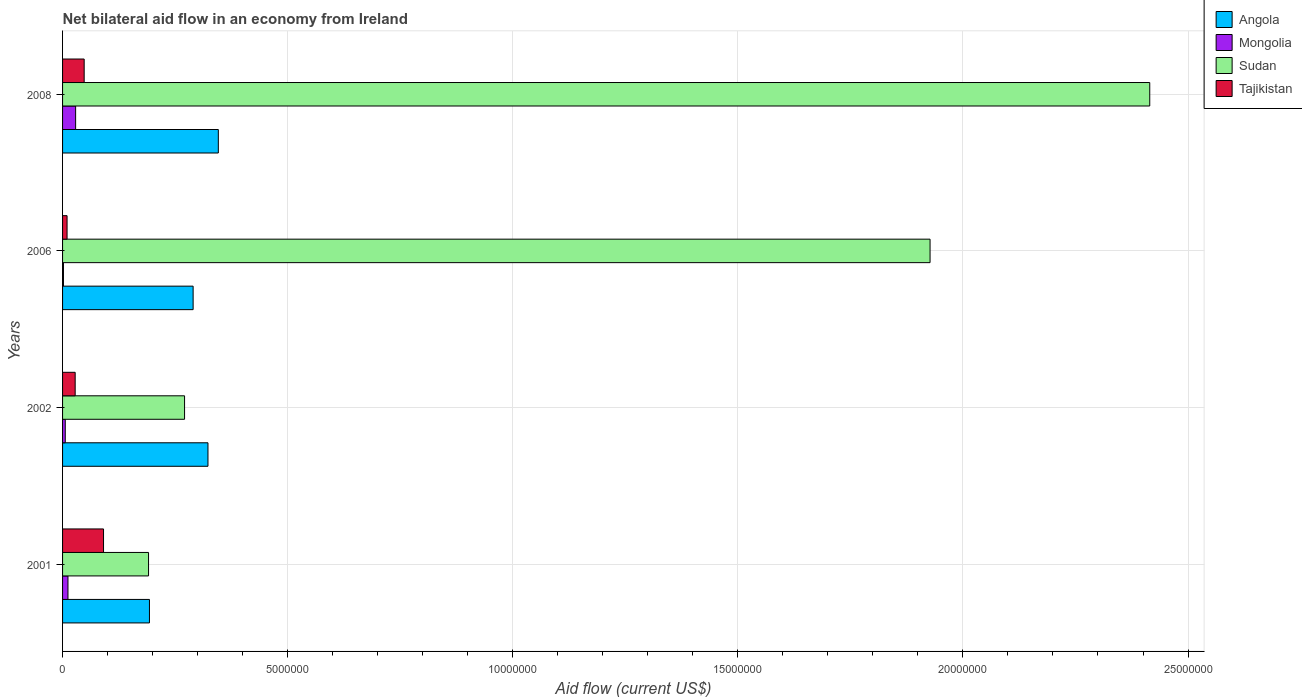How many different coloured bars are there?
Your response must be concise. 4. How many groups of bars are there?
Your response must be concise. 4. Are the number of bars per tick equal to the number of legend labels?
Your answer should be compact. Yes. Are the number of bars on each tick of the Y-axis equal?
Keep it short and to the point. Yes. How many bars are there on the 4th tick from the bottom?
Your response must be concise. 4. What is the net bilateral aid flow in Sudan in 2008?
Your answer should be compact. 2.42e+07. Across all years, what is the maximum net bilateral aid flow in Mongolia?
Your answer should be compact. 2.90e+05. In which year was the net bilateral aid flow in Tajikistan maximum?
Offer a very short reply. 2001. What is the total net bilateral aid flow in Sudan in the graph?
Give a very brief answer. 4.80e+07. What is the difference between the net bilateral aid flow in Angola in 2008 and the net bilateral aid flow in Sudan in 2002?
Provide a short and direct response. 7.50e+05. What is the average net bilateral aid flow in Tajikistan per year?
Make the answer very short. 4.42e+05. In the year 2001, what is the difference between the net bilateral aid flow in Mongolia and net bilateral aid flow in Sudan?
Offer a very short reply. -1.79e+06. In how many years, is the net bilateral aid flow in Mongolia greater than 5000000 US$?
Offer a very short reply. 0. What is the ratio of the net bilateral aid flow in Angola in 2001 to that in 2006?
Your answer should be compact. 0.67. What is the difference between the highest and the lowest net bilateral aid flow in Tajikistan?
Provide a succinct answer. 8.10e+05. In how many years, is the net bilateral aid flow in Mongolia greater than the average net bilateral aid flow in Mongolia taken over all years?
Your answer should be compact. 1. Is the sum of the net bilateral aid flow in Angola in 2002 and 2006 greater than the maximum net bilateral aid flow in Mongolia across all years?
Make the answer very short. Yes. What does the 4th bar from the top in 2008 represents?
Make the answer very short. Angola. What does the 1st bar from the bottom in 2006 represents?
Offer a very short reply. Angola. Is it the case that in every year, the sum of the net bilateral aid flow in Angola and net bilateral aid flow in Sudan is greater than the net bilateral aid flow in Tajikistan?
Provide a succinct answer. Yes. Are all the bars in the graph horizontal?
Keep it short and to the point. Yes. What is the difference between two consecutive major ticks on the X-axis?
Offer a very short reply. 5.00e+06. Does the graph contain grids?
Offer a very short reply. Yes. How many legend labels are there?
Offer a terse response. 4. How are the legend labels stacked?
Your answer should be compact. Vertical. What is the title of the graph?
Give a very brief answer. Net bilateral aid flow in an economy from Ireland. Does "United States" appear as one of the legend labels in the graph?
Provide a short and direct response. No. What is the label or title of the X-axis?
Your response must be concise. Aid flow (current US$). What is the Aid flow (current US$) of Angola in 2001?
Your response must be concise. 1.93e+06. What is the Aid flow (current US$) of Mongolia in 2001?
Offer a very short reply. 1.20e+05. What is the Aid flow (current US$) in Sudan in 2001?
Your answer should be compact. 1.91e+06. What is the Aid flow (current US$) of Tajikistan in 2001?
Keep it short and to the point. 9.10e+05. What is the Aid flow (current US$) in Angola in 2002?
Keep it short and to the point. 3.23e+06. What is the Aid flow (current US$) in Mongolia in 2002?
Provide a succinct answer. 6.00e+04. What is the Aid flow (current US$) of Sudan in 2002?
Ensure brevity in your answer.  2.71e+06. What is the Aid flow (current US$) of Angola in 2006?
Give a very brief answer. 2.90e+06. What is the Aid flow (current US$) in Mongolia in 2006?
Provide a short and direct response. 2.00e+04. What is the Aid flow (current US$) in Sudan in 2006?
Make the answer very short. 1.93e+07. What is the Aid flow (current US$) of Tajikistan in 2006?
Your answer should be compact. 1.00e+05. What is the Aid flow (current US$) of Angola in 2008?
Offer a terse response. 3.46e+06. What is the Aid flow (current US$) in Mongolia in 2008?
Provide a short and direct response. 2.90e+05. What is the Aid flow (current US$) in Sudan in 2008?
Offer a terse response. 2.42e+07. What is the Aid flow (current US$) of Tajikistan in 2008?
Keep it short and to the point. 4.80e+05. Across all years, what is the maximum Aid flow (current US$) in Angola?
Your answer should be very brief. 3.46e+06. Across all years, what is the maximum Aid flow (current US$) in Sudan?
Offer a terse response. 2.42e+07. Across all years, what is the maximum Aid flow (current US$) of Tajikistan?
Provide a succinct answer. 9.10e+05. Across all years, what is the minimum Aid flow (current US$) in Angola?
Your answer should be very brief. 1.93e+06. Across all years, what is the minimum Aid flow (current US$) of Sudan?
Provide a short and direct response. 1.91e+06. Across all years, what is the minimum Aid flow (current US$) of Tajikistan?
Offer a very short reply. 1.00e+05. What is the total Aid flow (current US$) in Angola in the graph?
Ensure brevity in your answer.  1.15e+07. What is the total Aid flow (current US$) of Mongolia in the graph?
Provide a succinct answer. 4.90e+05. What is the total Aid flow (current US$) in Sudan in the graph?
Your answer should be compact. 4.80e+07. What is the total Aid flow (current US$) of Tajikistan in the graph?
Provide a succinct answer. 1.77e+06. What is the difference between the Aid flow (current US$) in Angola in 2001 and that in 2002?
Offer a terse response. -1.30e+06. What is the difference between the Aid flow (current US$) of Sudan in 2001 and that in 2002?
Your response must be concise. -8.00e+05. What is the difference between the Aid flow (current US$) of Tajikistan in 2001 and that in 2002?
Your response must be concise. 6.30e+05. What is the difference between the Aid flow (current US$) in Angola in 2001 and that in 2006?
Your response must be concise. -9.70e+05. What is the difference between the Aid flow (current US$) of Mongolia in 2001 and that in 2006?
Provide a succinct answer. 1.00e+05. What is the difference between the Aid flow (current US$) of Sudan in 2001 and that in 2006?
Keep it short and to the point. -1.74e+07. What is the difference between the Aid flow (current US$) in Tajikistan in 2001 and that in 2006?
Your answer should be very brief. 8.10e+05. What is the difference between the Aid flow (current US$) of Angola in 2001 and that in 2008?
Offer a terse response. -1.53e+06. What is the difference between the Aid flow (current US$) of Sudan in 2001 and that in 2008?
Provide a succinct answer. -2.22e+07. What is the difference between the Aid flow (current US$) of Mongolia in 2002 and that in 2006?
Offer a terse response. 4.00e+04. What is the difference between the Aid flow (current US$) of Sudan in 2002 and that in 2006?
Make the answer very short. -1.66e+07. What is the difference between the Aid flow (current US$) in Tajikistan in 2002 and that in 2006?
Give a very brief answer. 1.80e+05. What is the difference between the Aid flow (current US$) in Angola in 2002 and that in 2008?
Your answer should be very brief. -2.30e+05. What is the difference between the Aid flow (current US$) in Sudan in 2002 and that in 2008?
Keep it short and to the point. -2.14e+07. What is the difference between the Aid flow (current US$) of Angola in 2006 and that in 2008?
Your response must be concise. -5.60e+05. What is the difference between the Aid flow (current US$) in Mongolia in 2006 and that in 2008?
Provide a short and direct response. -2.70e+05. What is the difference between the Aid flow (current US$) in Sudan in 2006 and that in 2008?
Your response must be concise. -4.88e+06. What is the difference between the Aid flow (current US$) of Tajikistan in 2006 and that in 2008?
Provide a short and direct response. -3.80e+05. What is the difference between the Aid flow (current US$) of Angola in 2001 and the Aid flow (current US$) of Mongolia in 2002?
Make the answer very short. 1.87e+06. What is the difference between the Aid flow (current US$) in Angola in 2001 and the Aid flow (current US$) in Sudan in 2002?
Give a very brief answer. -7.80e+05. What is the difference between the Aid flow (current US$) of Angola in 2001 and the Aid flow (current US$) of Tajikistan in 2002?
Give a very brief answer. 1.65e+06. What is the difference between the Aid flow (current US$) in Mongolia in 2001 and the Aid flow (current US$) in Sudan in 2002?
Make the answer very short. -2.59e+06. What is the difference between the Aid flow (current US$) in Mongolia in 2001 and the Aid flow (current US$) in Tajikistan in 2002?
Ensure brevity in your answer.  -1.60e+05. What is the difference between the Aid flow (current US$) in Sudan in 2001 and the Aid flow (current US$) in Tajikistan in 2002?
Ensure brevity in your answer.  1.63e+06. What is the difference between the Aid flow (current US$) of Angola in 2001 and the Aid flow (current US$) of Mongolia in 2006?
Make the answer very short. 1.91e+06. What is the difference between the Aid flow (current US$) in Angola in 2001 and the Aid flow (current US$) in Sudan in 2006?
Give a very brief answer. -1.73e+07. What is the difference between the Aid flow (current US$) of Angola in 2001 and the Aid flow (current US$) of Tajikistan in 2006?
Ensure brevity in your answer.  1.83e+06. What is the difference between the Aid flow (current US$) of Mongolia in 2001 and the Aid flow (current US$) of Sudan in 2006?
Offer a very short reply. -1.92e+07. What is the difference between the Aid flow (current US$) in Mongolia in 2001 and the Aid flow (current US$) in Tajikistan in 2006?
Offer a very short reply. 2.00e+04. What is the difference between the Aid flow (current US$) in Sudan in 2001 and the Aid flow (current US$) in Tajikistan in 2006?
Offer a terse response. 1.81e+06. What is the difference between the Aid flow (current US$) in Angola in 2001 and the Aid flow (current US$) in Mongolia in 2008?
Offer a terse response. 1.64e+06. What is the difference between the Aid flow (current US$) of Angola in 2001 and the Aid flow (current US$) of Sudan in 2008?
Provide a succinct answer. -2.22e+07. What is the difference between the Aid flow (current US$) in Angola in 2001 and the Aid flow (current US$) in Tajikistan in 2008?
Give a very brief answer. 1.45e+06. What is the difference between the Aid flow (current US$) in Mongolia in 2001 and the Aid flow (current US$) in Sudan in 2008?
Provide a short and direct response. -2.40e+07. What is the difference between the Aid flow (current US$) of Mongolia in 2001 and the Aid flow (current US$) of Tajikistan in 2008?
Your answer should be very brief. -3.60e+05. What is the difference between the Aid flow (current US$) of Sudan in 2001 and the Aid flow (current US$) of Tajikistan in 2008?
Provide a succinct answer. 1.43e+06. What is the difference between the Aid flow (current US$) of Angola in 2002 and the Aid flow (current US$) of Mongolia in 2006?
Make the answer very short. 3.21e+06. What is the difference between the Aid flow (current US$) in Angola in 2002 and the Aid flow (current US$) in Sudan in 2006?
Your answer should be compact. -1.60e+07. What is the difference between the Aid flow (current US$) in Angola in 2002 and the Aid flow (current US$) in Tajikistan in 2006?
Provide a succinct answer. 3.13e+06. What is the difference between the Aid flow (current US$) of Mongolia in 2002 and the Aid flow (current US$) of Sudan in 2006?
Your answer should be very brief. -1.92e+07. What is the difference between the Aid flow (current US$) in Sudan in 2002 and the Aid flow (current US$) in Tajikistan in 2006?
Provide a short and direct response. 2.61e+06. What is the difference between the Aid flow (current US$) in Angola in 2002 and the Aid flow (current US$) in Mongolia in 2008?
Keep it short and to the point. 2.94e+06. What is the difference between the Aid flow (current US$) of Angola in 2002 and the Aid flow (current US$) of Sudan in 2008?
Provide a succinct answer. -2.09e+07. What is the difference between the Aid flow (current US$) in Angola in 2002 and the Aid flow (current US$) in Tajikistan in 2008?
Provide a succinct answer. 2.75e+06. What is the difference between the Aid flow (current US$) of Mongolia in 2002 and the Aid flow (current US$) of Sudan in 2008?
Keep it short and to the point. -2.41e+07. What is the difference between the Aid flow (current US$) of Mongolia in 2002 and the Aid flow (current US$) of Tajikistan in 2008?
Keep it short and to the point. -4.20e+05. What is the difference between the Aid flow (current US$) in Sudan in 2002 and the Aid flow (current US$) in Tajikistan in 2008?
Keep it short and to the point. 2.23e+06. What is the difference between the Aid flow (current US$) in Angola in 2006 and the Aid flow (current US$) in Mongolia in 2008?
Keep it short and to the point. 2.61e+06. What is the difference between the Aid flow (current US$) of Angola in 2006 and the Aid flow (current US$) of Sudan in 2008?
Make the answer very short. -2.12e+07. What is the difference between the Aid flow (current US$) of Angola in 2006 and the Aid flow (current US$) of Tajikistan in 2008?
Provide a short and direct response. 2.42e+06. What is the difference between the Aid flow (current US$) in Mongolia in 2006 and the Aid flow (current US$) in Sudan in 2008?
Offer a very short reply. -2.41e+07. What is the difference between the Aid flow (current US$) of Mongolia in 2006 and the Aid flow (current US$) of Tajikistan in 2008?
Keep it short and to the point. -4.60e+05. What is the difference between the Aid flow (current US$) of Sudan in 2006 and the Aid flow (current US$) of Tajikistan in 2008?
Your response must be concise. 1.88e+07. What is the average Aid flow (current US$) of Angola per year?
Offer a very short reply. 2.88e+06. What is the average Aid flow (current US$) in Mongolia per year?
Offer a very short reply. 1.22e+05. What is the average Aid flow (current US$) in Sudan per year?
Make the answer very short. 1.20e+07. What is the average Aid flow (current US$) of Tajikistan per year?
Provide a succinct answer. 4.42e+05. In the year 2001, what is the difference between the Aid flow (current US$) in Angola and Aid flow (current US$) in Mongolia?
Provide a short and direct response. 1.81e+06. In the year 2001, what is the difference between the Aid flow (current US$) of Angola and Aid flow (current US$) of Tajikistan?
Keep it short and to the point. 1.02e+06. In the year 2001, what is the difference between the Aid flow (current US$) of Mongolia and Aid flow (current US$) of Sudan?
Keep it short and to the point. -1.79e+06. In the year 2001, what is the difference between the Aid flow (current US$) in Mongolia and Aid flow (current US$) in Tajikistan?
Keep it short and to the point. -7.90e+05. In the year 2002, what is the difference between the Aid flow (current US$) in Angola and Aid flow (current US$) in Mongolia?
Offer a very short reply. 3.17e+06. In the year 2002, what is the difference between the Aid flow (current US$) in Angola and Aid flow (current US$) in Sudan?
Make the answer very short. 5.20e+05. In the year 2002, what is the difference between the Aid flow (current US$) in Angola and Aid flow (current US$) in Tajikistan?
Offer a terse response. 2.95e+06. In the year 2002, what is the difference between the Aid flow (current US$) in Mongolia and Aid flow (current US$) in Sudan?
Provide a short and direct response. -2.65e+06. In the year 2002, what is the difference between the Aid flow (current US$) in Mongolia and Aid flow (current US$) in Tajikistan?
Keep it short and to the point. -2.20e+05. In the year 2002, what is the difference between the Aid flow (current US$) of Sudan and Aid flow (current US$) of Tajikistan?
Offer a very short reply. 2.43e+06. In the year 2006, what is the difference between the Aid flow (current US$) of Angola and Aid flow (current US$) of Mongolia?
Offer a terse response. 2.88e+06. In the year 2006, what is the difference between the Aid flow (current US$) of Angola and Aid flow (current US$) of Sudan?
Provide a succinct answer. -1.64e+07. In the year 2006, what is the difference between the Aid flow (current US$) of Angola and Aid flow (current US$) of Tajikistan?
Provide a short and direct response. 2.80e+06. In the year 2006, what is the difference between the Aid flow (current US$) in Mongolia and Aid flow (current US$) in Sudan?
Your answer should be compact. -1.92e+07. In the year 2006, what is the difference between the Aid flow (current US$) of Sudan and Aid flow (current US$) of Tajikistan?
Give a very brief answer. 1.92e+07. In the year 2008, what is the difference between the Aid flow (current US$) in Angola and Aid flow (current US$) in Mongolia?
Provide a short and direct response. 3.17e+06. In the year 2008, what is the difference between the Aid flow (current US$) in Angola and Aid flow (current US$) in Sudan?
Your answer should be compact. -2.07e+07. In the year 2008, what is the difference between the Aid flow (current US$) in Angola and Aid flow (current US$) in Tajikistan?
Provide a short and direct response. 2.98e+06. In the year 2008, what is the difference between the Aid flow (current US$) in Mongolia and Aid flow (current US$) in Sudan?
Provide a succinct answer. -2.39e+07. In the year 2008, what is the difference between the Aid flow (current US$) of Sudan and Aid flow (current US$) of Tajikistan?
Your answer should be very brief. 2.37e+07. What is the ratio of the Aid flow (current US$) of Angola in 2001 to that in 2002?
Make the answer very short. 0.6. What is the ratio of the Aid flow (current US$) in Mongolia in 2001 to that in 2002?
Make the answer very short. 2. What is the ratio of the Aid flow (current US$) of Sudan in 2001 to that in 2002?
Ensure brevity in your answer.  0.7. What is the ratio of the Aid flow (current US$) in Tajikistan in 2001 to that in 2002?
Your answer should be very brief. 3.25. What is the ratio of the Aid flow (current US$) of Angola in 2001 to that in 2006?
Give a very brief answer. 0.67. What is the ratio of the Aid flow (current US$) in Sudan in 2001 to that in 2006?
Offer a very short reply. 0.1. What is the ratio of the Aid flow (current US$) in Tajikistan in 2001 to that in 2006?
Your answer should be very brief. 9.1. What is the ratio of the Aid flow (current US$) of Angola in 2001 to that in 2008?
Offer a very short reply. 0.56. What is the ratio of the Aid flow (current US$) of Mongolia in 2001 to that in 2008?
Your answer should be very brief. 0.41. What is the ratio of the Aid flow (current US$) in Sudan in 2001 to that in 2008?
Offer a very short reply. 0.08. What is the ratio of the Aid flow (current US$) of Tajikistan in 2001 to that in 2008?
Make the answer very short. 1.9. What is the ratio of the Aid flow (current US$) of Angola in 2002 to that in 2006?
Ensure brevity in your answer.  1.11. What is the ratio of the Aid flow (current US$) in Mongolia in 2002 to that in 2006?
Your answer should be compact. 3. What is the ratio of the Aid flow (current US$) in Sudan in 2002 to that in 2006?
Your answer should be very brief. 0.14. What is the ratio of the Aid flow (current US$) in Angola in 2002 to that in 2008?
Ensure brevity in your answer.  0.93. What is the ratio of the Aid flow (current US$) in Mongolia in 2002 to that in 2008?
Make the answer very short. 0.21. What is the ratio of the Aid flow (current US$) in Sudan in 2002 to that in 2008?
Your response must be concise. 0.11. What is the ratio of the Aid flow (current US$) of Tajikistan in 2002 to that in 2008?
Ensure brevity in your answer.  0.58. What is the ratio of the Aid flow (current US$) in Angola in 2006 to that in 2008?
Give a very brief answer. 0.84. What is the ratio of the Aid flow (current US$) in Mongolia in 2006 to that in 2008?
Make the answer very short. 0.07. What is the ratio of the Aid flow (current US$) of Sudan in 2006 to that in 2008?
Ensure brevity in your answer.  0.8. What is the ratio of the Aid flow (current US$) of Tajikistan in 2006 to that in 2008?
Provide a short and direct response. 0.21. What is the difference between the highest and the second highest Aid flow (current US$) in Mongolia?
Offer a very short reply. 1.70e+05. What is the difference between the highest and the second highest Aid flow (current US$) of Sudan?
Provide a short and direct response. 4.88e+06. What is the difference between the highest and the second highest Aid flow (current US$) of Tajikistan?
Give a very brief answer. 4.30e+05. What is the difference between the highest and the lowest Aid flow (current US$) in Angola?
Your response must be concise. 1.53e+06. What is the difference between the highest and the lowest Aid flow (current US$) of Sudan?
Your answer should be very brief. 2.22e+07. What is the difference between the highest and the lowest Aid flow (current US$) of Tajikistan?
Provide a short and direct response. 8.10e+05. 